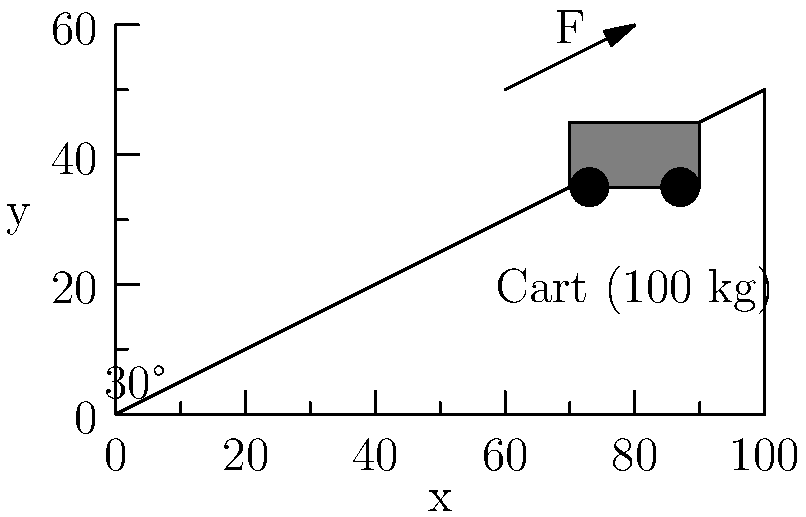As the librarian at Kilkenny Public Library, you need to move a loaded book cart up a ramp. The cart and books have a combined mass of 100 kg, and the ramp makes an angle of 30° with the horizontal. Assuming the coefficient of friction between the cart and the ramp is 0.2, what is the magnitude of the force parallel to the ramp required to move the cart up at a constant speed? To solve this problem, let's follow these steps:

1. Identify the forces acting on the cart:
   - Weight (W) = mg, pointing downward
   - Normal force (N), perpendicular to the ramp
   - Friction force (f), parallel to the ramp and opposing motion
   - Applied force (F), parallel to the ramp

2. Calculate the weight:
   W = mg = 100 kg × 9.8 m/s² = 980 N

3. Resolve the weight into components parallel and perpendicular to the ramp:
   W_parallel = W sin(30°) = 980 N × 0.5 = 490 N
   W_perpendicular = W cos(30°) = 980 N × 0.866 = 848.68 N

4. The normal force is equal to the perpendicular component of the weight:
   N = 848.68 N

5. Calculate the friction force:
   f = μN = 0.2 × 848.68 N = 169.74 N

6. For constant speed, the sum of forces parallel to the ramp must be zero:
   F - f - W_parallel = 0
   F = f + W_parallel
   F = 169.74 N + 490 N = 659.74 N

Therefore, the magnitude of the force required to move the cart up the ramp at constant speed is approximately 659.74 N.
Answer: 659.74 N 